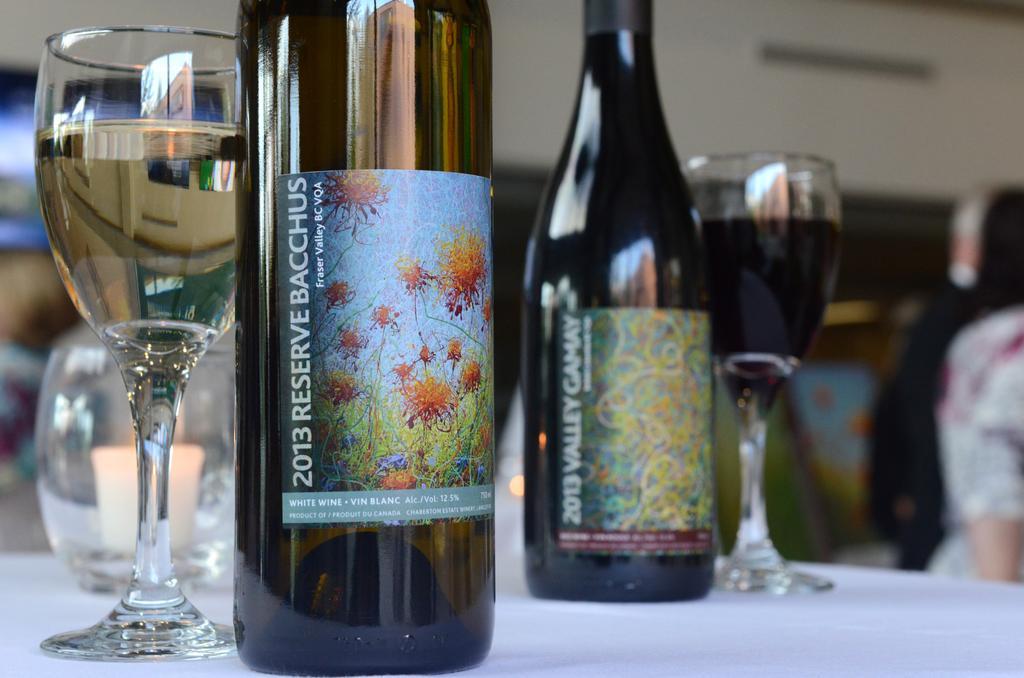Can you describe this image briefly? These are bottles and glasses, this is human hand. 